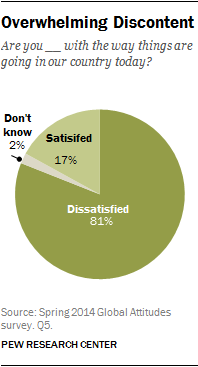List a handful of essential elements in this visual. The difference in value between Satisfied and Dissatisfied is 64. The value of the Satisfied segment is 17. 